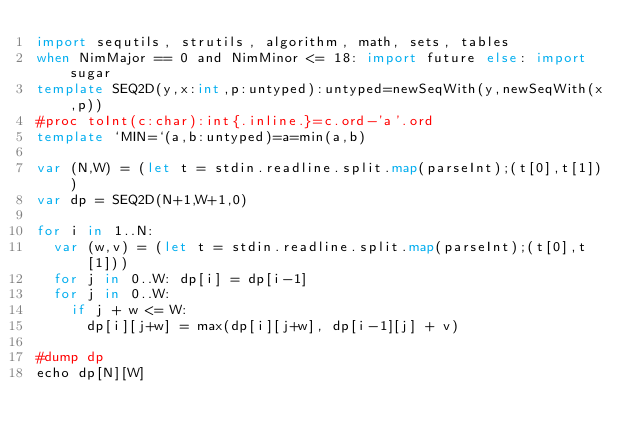<code> <loc_0><loc_0><loc_500><loc_500><_Nim_>import sequtils, strutils, algorithm, math, sets, tables
when NimMajor == 0 and NimMinor <= 18: import future else: import sugar
template SEQ2D(y,x:int,p:untyped):untyped=newSeqWith(y,newSeqWith(x,p))
#proc toInt(c:char):int{.inline.}=c.ord-'a'.ord 
template `MIN=`(a,b:untyped)=a=min(a,b)

var (N,W) = (let t = stdin.readline.split.map(parseInt);(t[0],t[1]))
var dp = SEQ2D(N+1,W+1,0)

for i in 1..N:
  var (w,v) = (let t = stdin.readline.split.map(parseInt);(t[0],t[1]))
  for j in 0..W: dp[i] = dp[i-1]
  for j in 0..W:
    if j + w <= W:
      dp[i][j+w] = max(dp[i][j+w], dp[i-1][j] + v)

#dump dp
echo dp[N][W]</code> 